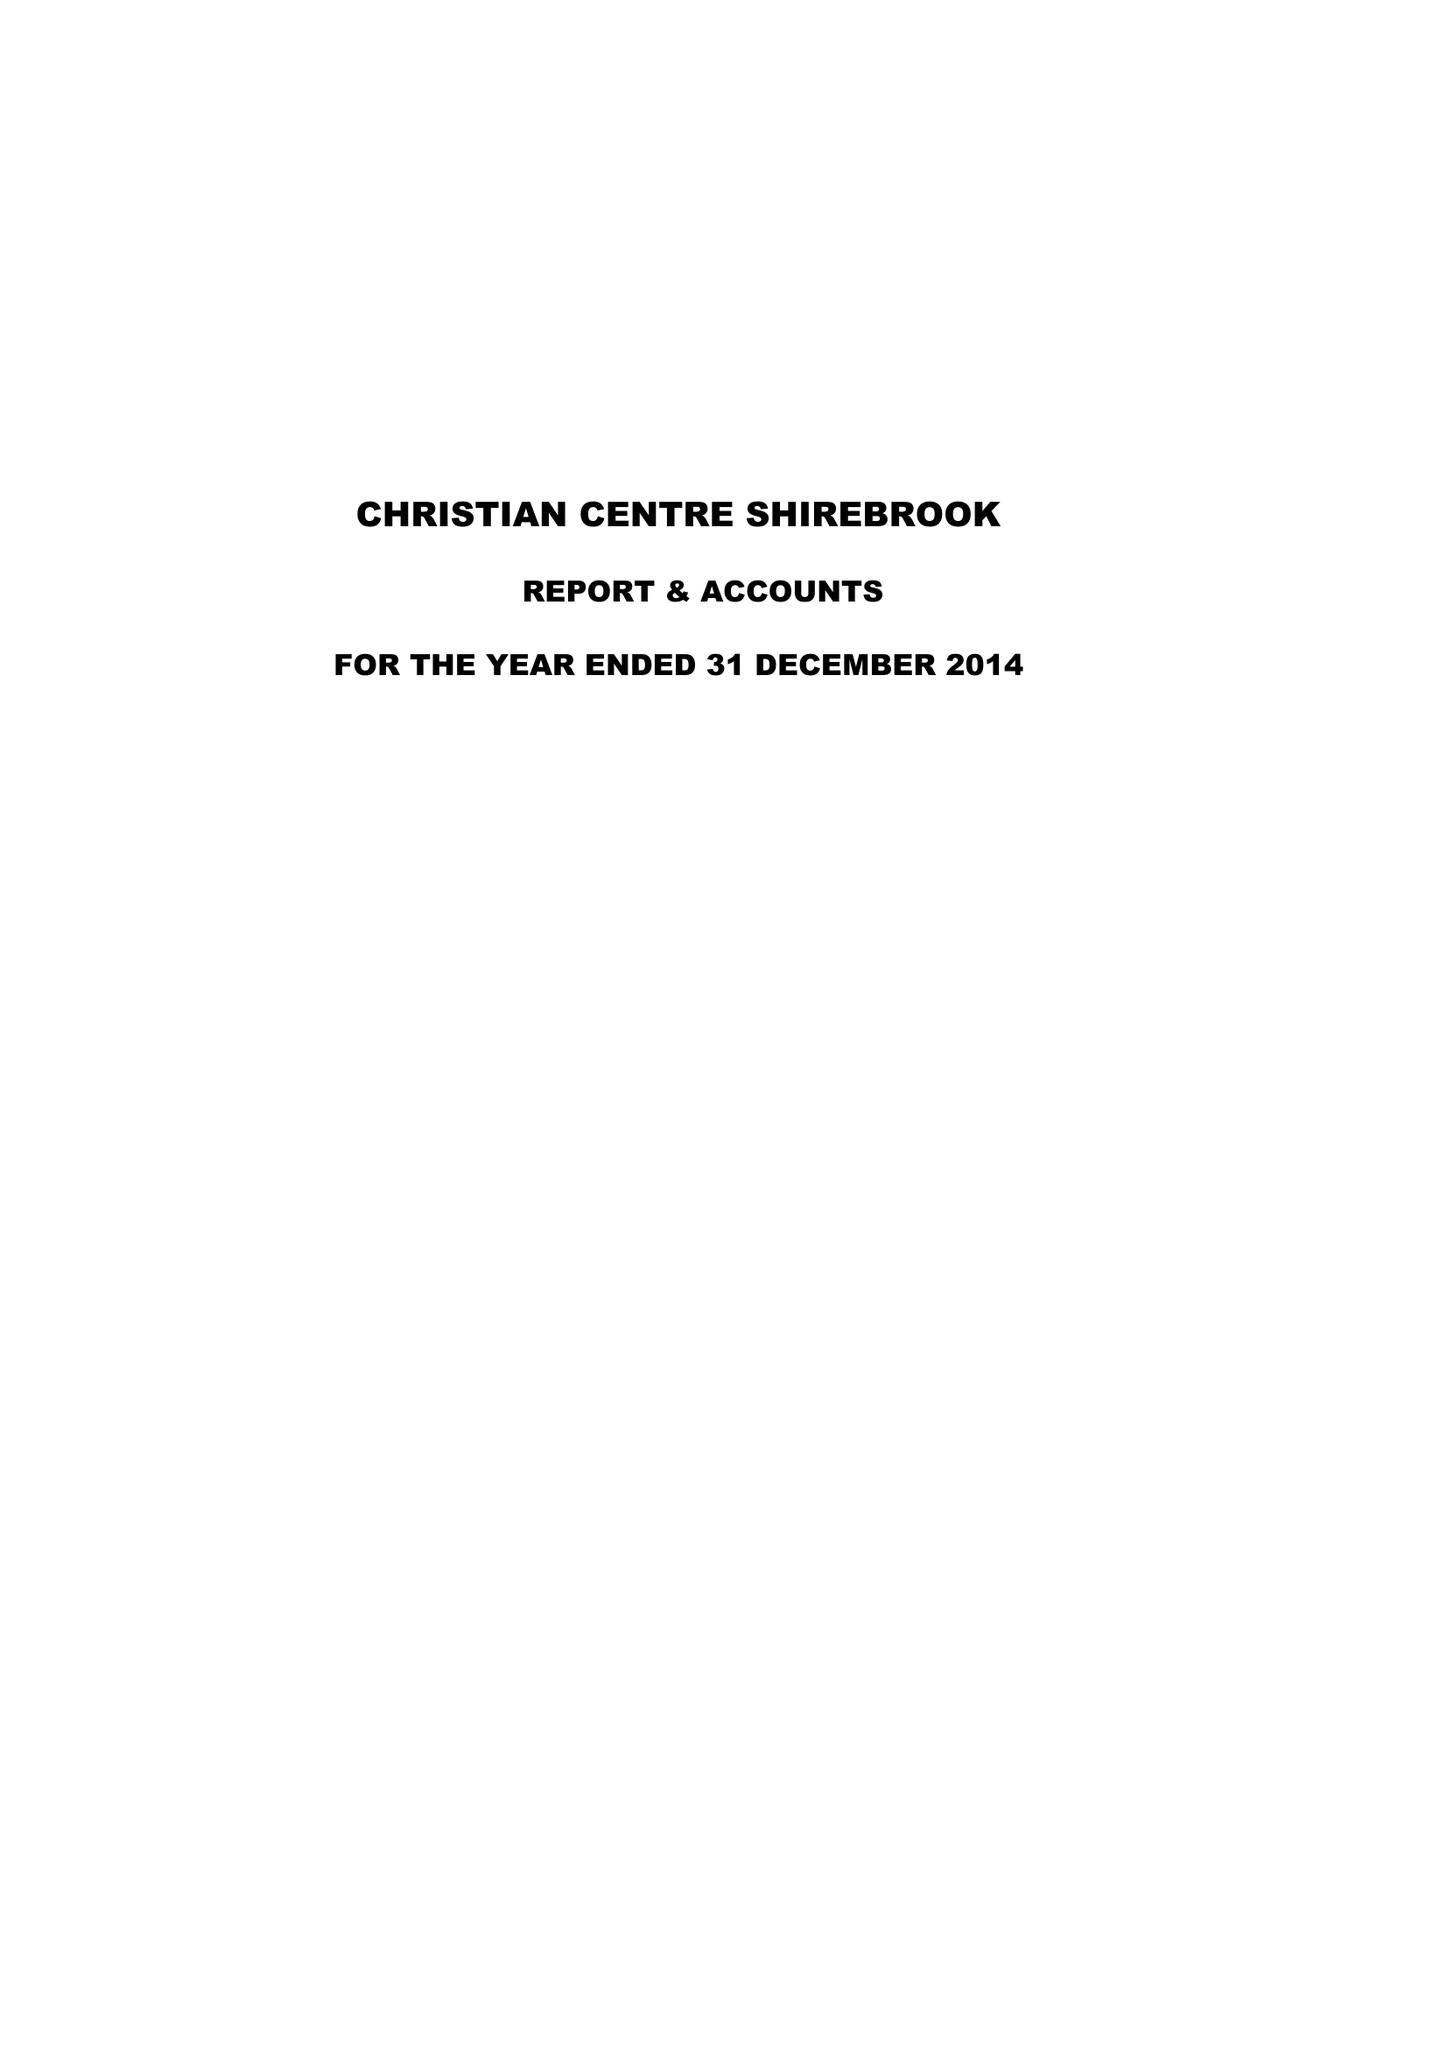What is the value for the report_date?
Answer the question using a single word or phrase. 2014-12-31 